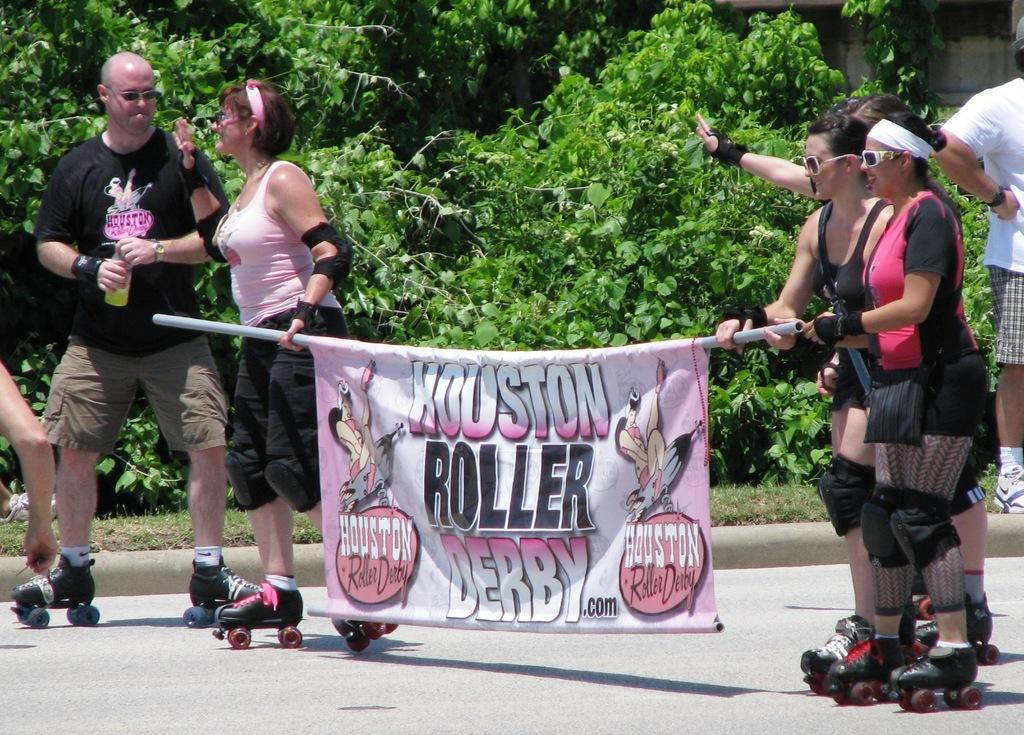Describe this image in one or two sentences. In this image I can see few people, I can see most of them are wearing shades and roller skating shoes. I can also see a pink colour banner and on it I can see something is written. In the background I can see few trees and I can see few of them are holding a pipe over here. I can also see he is holding a bottle. 